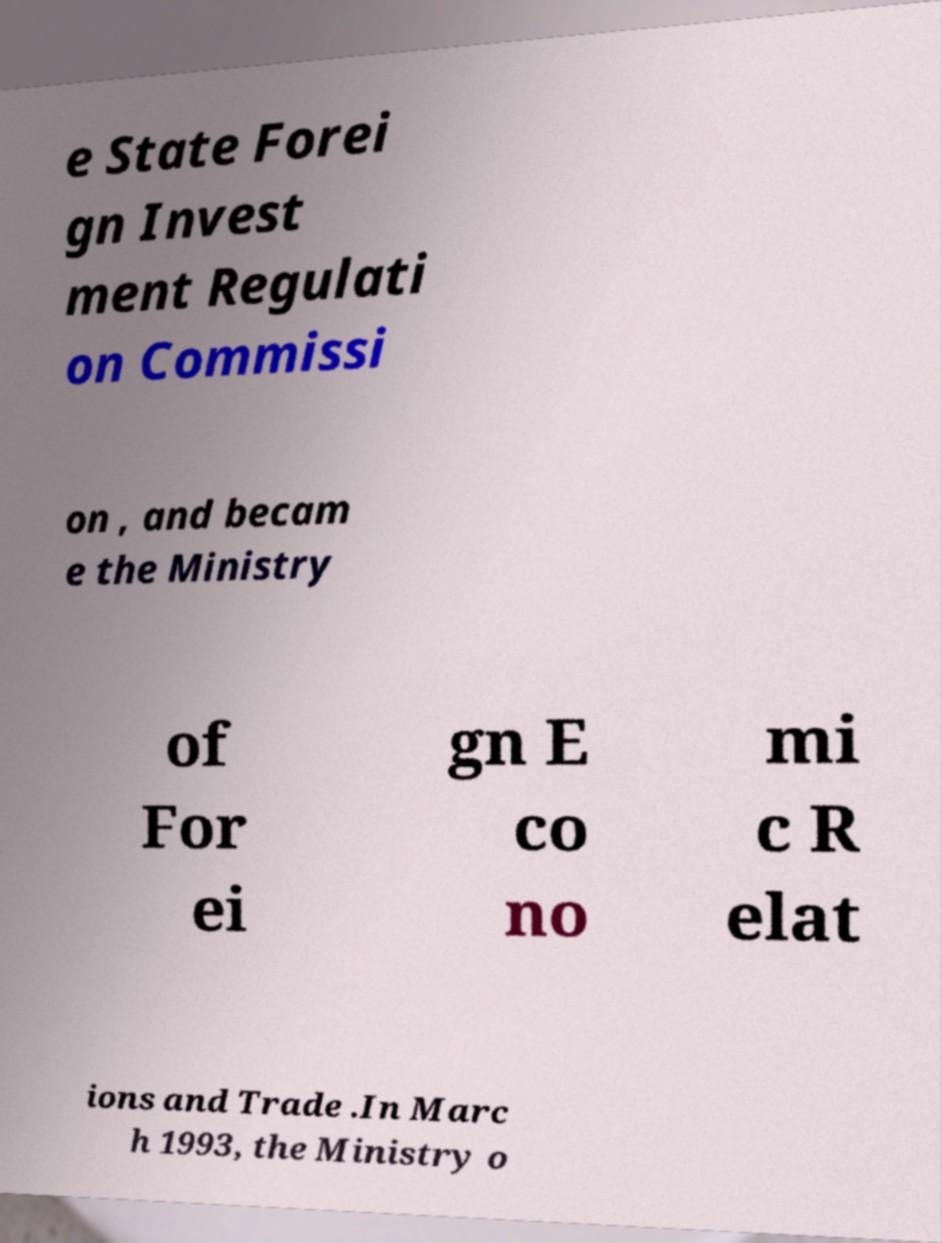For documentation purposes, I need the text within this image transcribed. Could you provide that? e State Forei gn Invest ment Regulati on Commissi on , and becam e the Ministry of For ei gn E co no mi c R elat ions and Trade .In Marc h 1993, the Ministry o 